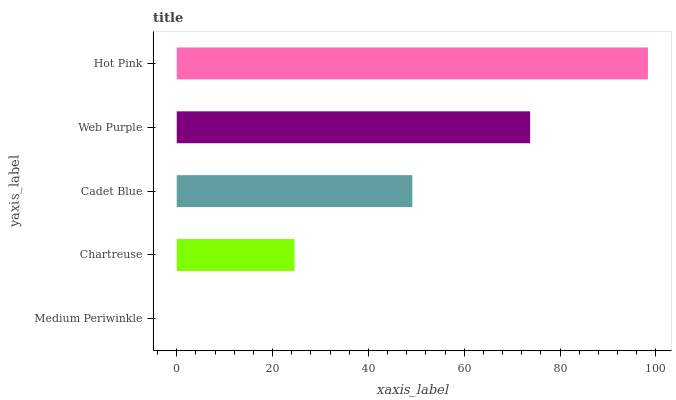Is Medium Periwinkle the minimum?
Answer yes or no. Yes. Is Hot Pink the maximum?
Answer yes or no. Yes. Is Chartreuse the minimum?
Answer yes or no. No. Is Chartreuse the maximum?
Answer yes or no. No. Is Chartreuse greater than Medium Periwinkle?
Answer yes or no. Yes. Is Medium Periwinkle less than Chartreuse?
Answer yes or no. Yes. Is Medium Periwinkle greater than Chartreuse?
Answer yes or no. No. Is Chartreuse less than Medium Periwinkle?
Answer yes or no. No. Is Cadet Blue the high median?
Answer yes or no. Yes. Is Cadet Blue the low median?
Answer yes or no. Yes. Is Web Purple the high median?
Answer yes or no. No. Is Hot Pink the low median?
Answer yes or no. No. 